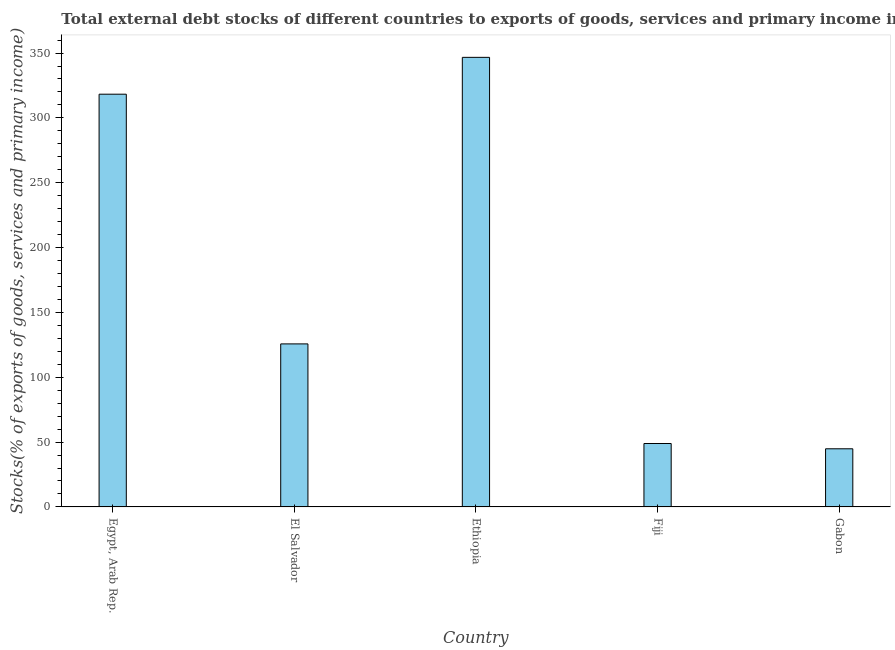What is the title of the graph?
Your response must be concise. Total external debt stocks of different countries to exports of goods, services and primary income in 1981. What is the label or title of the X-axis?
Your answer should be compact. Country. What is the label or title of the Y-axis?
Ensure brevity in your answer.  Stocks(% of exports of goods, services and primary income). What is the external debt stocks in Fiji?
Offer a very short reply. 48.9. Across all countries, what is the maximum external debt stocks?
Provide a succinct answer. 346.69. Across all countries, what is the minimum external debt stocks?
Provide a succinct answer. 44.83. In which country was the external debt stocks maximum?
Make the answer very short. Ethiopia. In which country was the external debt stocks minimum?
Give a very brief answer. Gabon. What is the sum of the external debt stocks?
Give a very brief answer. 884.43. What is the difference between the external debt stocks in Ethiopia and Fiji?
Ensure brevity in your answer.  297.79. What is the average external debt stocks per country?
Your answer should be very brief. 176.89. What is the median external debt stocks?
Your response must be concise. 125.72. In how many countries, is the external debt stocks greater than 170 %?
Your answer should be compact. 2. What is the ratio of the external debt stocks in Ethiopia to that in Fiji?
Your answer should be very brief. 7.09. Is the external debt stocks in Egypt, Arab Rep. less than that in El Salvador?
Offer a terse response. No. Is the difference between the external debt stocks in Egypt, Arab Rep. and El Salvador greater than the difference between any two countries?
Offer a terse response. No. What is the difference between the highest and the second highest external debt stocks?
Your answer should be very brief. 28.41. Is the sum of the external debt stocks in El Salvador and Ethiopia greater than the maximum external debt stocks across all countries?
Provide a succinct answer. Yes. What is the difference between the highest and the lowest external debt stocks?
Make the answer very short. 301.86. Are the values on the major ticks of Y-axis written in scientific E-notation?
Give a very brief answer. No. What is the Stocks(% of exports of goods, services and primary income) in Egypt, Arab Rep.?
Make the answer very short. 318.29. What is the Stocks(% of exports of goods, services and primary income) in El Salvador?
Offer a terse response. 125.72. What is the Stocks(% of exports of goods, services and primary income) of Ethiopia?
Your answer should be very brief. 346.69. What is the Stocks(% of exports of goods, services and primary income) of Fiji?
Provide a short and direct response. 48.9. What is the Stocks(% of exports of goods, services and primary income) of Gabon?
Keep it short and to the point. 44.83. What is the difference between the Stocks(% of exports of goods, services and primary income) in Egypt, Arab Rep. and El Salvador?
Give a very brief answer. 192.57. What is the difference between the Stocks(% of exports of goods, services and primary income) in Egypt, Arab Rep. and Ethiopia?
Your answer should be compact. -28.41. What is the difference between the Stocks(% of exports of goods, services and primary income) in Egypt, Arab Rep. and Fiji?
Offer a terse response. 269.38. What is the difference between the Stocks(% of exports of goods, services and primary income) in Egypt, Arab Rep. and Gabon?
Keep it short and to the point. 273.45. What is the difference between the Stocks(% of exports of goods, services and primary income) in El Salvador and Ethiopia?
Your answer should be very brief. -220.97. What is the difference between the Stocks(% of exports of goods, services and primary income) in El Salvador and Fiji?
Ensure brevity in your answer.  76.82. What is the difference between the Stocks(% of exports of goods, services and primary income) in El Salvador and Gabon?
Your response must be concise. 80.89. What is the difference between the Stocks(% of exports of goods, services and primary income) in Ethiopia and Fiji?
Your answer should be very brief. 297.79. What is the difference between the Stocks(% of exports of goods, services and primary income) in Ethiopia and Gabon?
Provide a succinct answer. 301.86. What is the difference between the Stocks(% of exports of goods, services and primary income) in Fiji and Gabon?
Offer a terse response. 4.07. What is the ratio of the Stocks(% of exports of goods, services and primary income) in Egypt, Arab Rep. to that in El Salvador?
Your answer should be compact. 2.53. What is the ratio of the Stocks(% of exports of goods, services and primary income) in Egypt, Arab Rep. to that in Ethiopia?
Offer a very short reply. 0.92. What is the ratio of the Stocks(% of exports of goods, services and primary income) in Egypt, Arab Rep. to that in Fiji?
Offer a terse response. 6.51. What is the ratio of the Stocks(% of exports of goods, services and primary income) in El Salvador to that in Ethiopia?
Give a very brief answer. 0.36. What is the ratio of the Stocks(% of exports of goods, services and primary income) in El Salvador to that in Fiji?
Offer a terse response. 2.57. What is the ratio of the Stocks(% of exports of goods, services and primary income) in El Salvador to that in Gabon?
Provide a short and direct response. 2.8. What is the ratio of the Stocks(% of exports of goods, services and primary income) in Ethiopia to that in Fiji?
Provide a short and direct response. 7.09. What is the ratio of the Stocks(% of exports of goods, services and primary income) in Ethiopia to that in Gabon?
Your answer should be very brief. 7.73. What is the ratio of the Stocks(% of exports of goods, services and primary income) in Fiji to that in Gabon?
Keep it short and to the point. 1.09. 